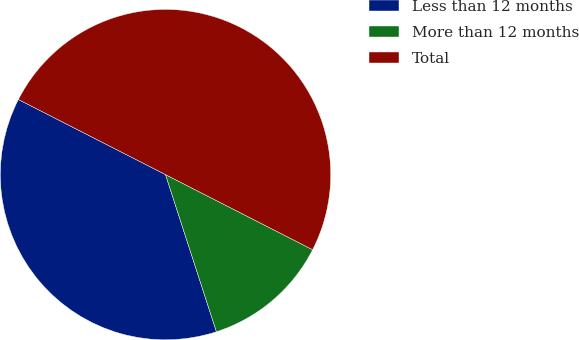Convert chart. <chart><loc_0><loc_0><loc_500><loc_500><pie_chart><fcel>Less than 12 months<fcel>More than 12 months<fcel>Total<nl><fcel>37.5%<fcel>12.5%<fcel>50.0%<nl></chart> 